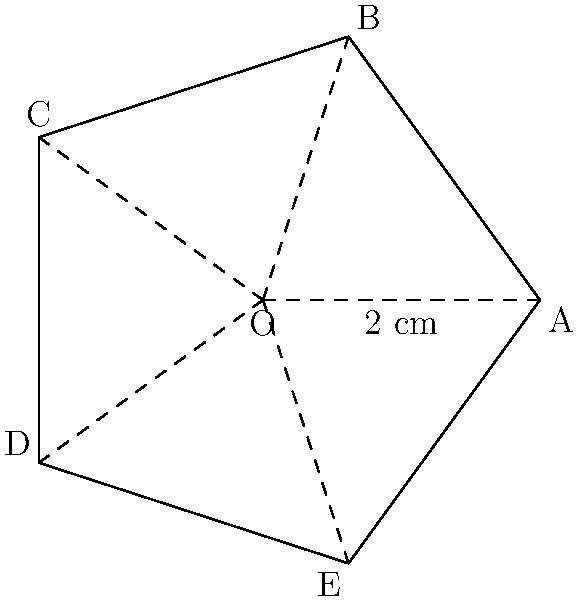For the local music Walk of Fame, you're designing a star-shaped plaque to honor the town's famous rock star. The star is a regular pentagon with five equal points, as shown in the diagram. If the distance from the center (O) to any vertex (A, B, C, D, or E) is 2 cm, what is the total area of the star-shaped plaque in square centimeters? To find the area of the star-shaped plaque, we'll follow these steps:

1) The star is composed of a regular pentagon and five isosceles triangles.

2) First, let's calculate the area of the pentagon:
   a) The central angle of a regular pentagon is $\frac{360°}{5} = 72°$.
   b) Half of this angle is $36°$.
   c) The area of the pentagon is given by $A_p = \frac{5}{4}r^2 \tan(36°)$, where $r$ is the radius (2 cm).
   d) $A_p = \frac{5}{4}(2^2) \tan(36°) \approx 7.2654$ cm².

3) Now, let's calculate the area of one isosceles triangle:
   a) The base angle of the isosceles triangle is $18°$ (half of $36°$).
   b) The height of the triangle is $h = 2 \sin(18°) \approx 0.6180$ cm.
   c) The base of the triangle is $2 \sin(36°) \approx 1.1756$ cm.
   d) The area of one triangle is $A_t = \frac{1}{2} * 1.1756 * 0.6180 \approx 0.3633$ cm².

4) The total area of the five triangles is $5 * 0.3633 = 1.8165$ cm².

5) The total area of the star is the sum of the pentagon area and the five triangles:
   $A_{total} = 7.2654 + 1.8165 = 9.0819$ cm².

Therefore, the total area of the star-shaped plaque is approximately 9.08 cm².
Answer: 9.08 cm² 